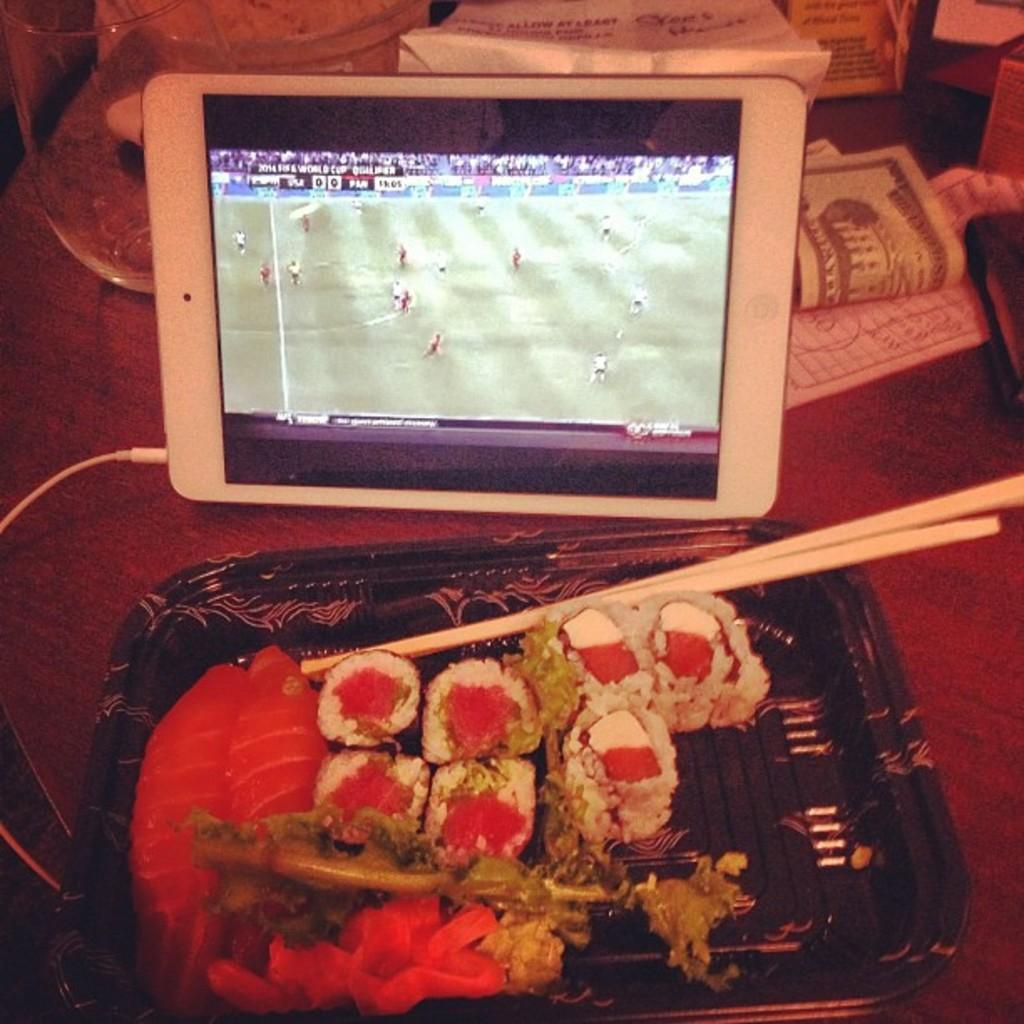What type of furniture is in the image? There is a table in the image. What can be seen on the table? Money, a glass, a tab, and a tray are present on the table. What is the tab connected to? The tab is connected to a wire. What is on the tray? The tray contains food items and chopsticks. What type of news can be heard coming from the radio in the image? There is no radio present in the image, so it's not possible to determine what news might be heard. 